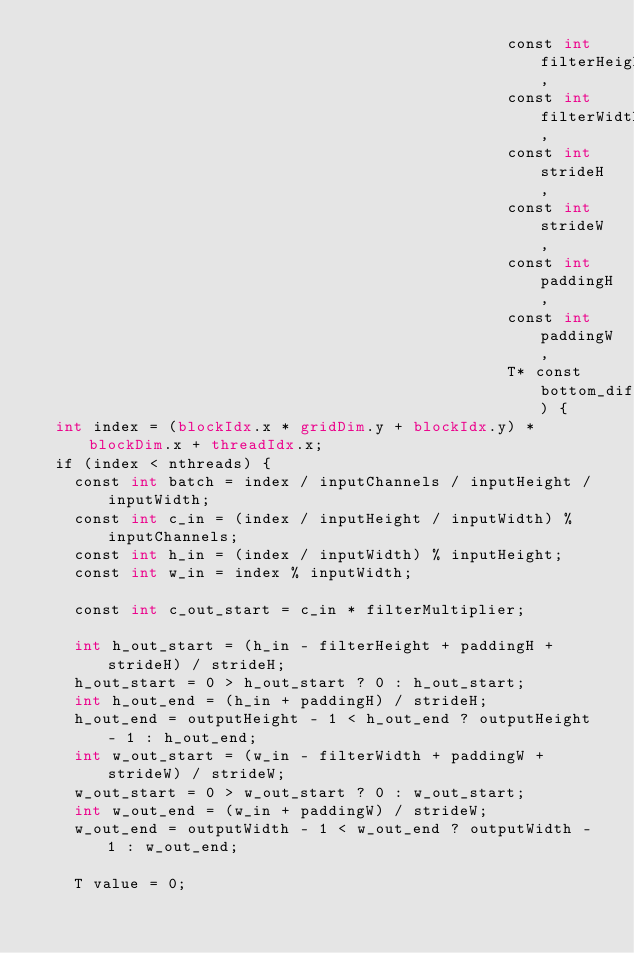Convert code to text. <code><loc_0><loc_0><loc_500><loc_500><_Cuda_>                                                  const int filterHeight,
                                                  const int filterWidth,
                                                  const int strideH,
                                                  const int strideW,
                                                  const int paddingH,
                                                  const int paddingW,
                                                  T* const bottom_diff) {
  int index = (blockIdx.x * gridDim.y + blockIdx.y) * blockDim.x + threadIdx.x;
  if (index < nthreads) {
    const int batch = index / inputChannels / inputHeight / inputWidth;
    const int c_in = (index / inputHeight / inputWidth) % inputChannels;
    const int h_in = (index / inputWidth) % inputHeight;
    const int w_in = index % inputWidth;

    const int c_out_start = c_in * filterMultiplier;

    int h_out_start = (h_in - filterHeight + paddingH + strideH) / strideH;
    h_out_start = 0 > h_out_start ? 0 : h_out_start;
    int h_out_end = (h_in + paddingH) / strideH;
    h_out_end = outputHeight - 1 < h_out_end ? outputHeight - 1 : h_out_end;
    int w_out_start = (w_in - filterWidth + paddingW + strideW) / strideW;
    w_out_start = 0 > w_out_start ? 0 : w_out_start;
    int w_out_end = (w_in + paddingW) / strideW;
    w_out_end = outputWidth - 1 < w_out_end ? outputWidth - 1 : w_out_end;

    T value = 0;
</code> 